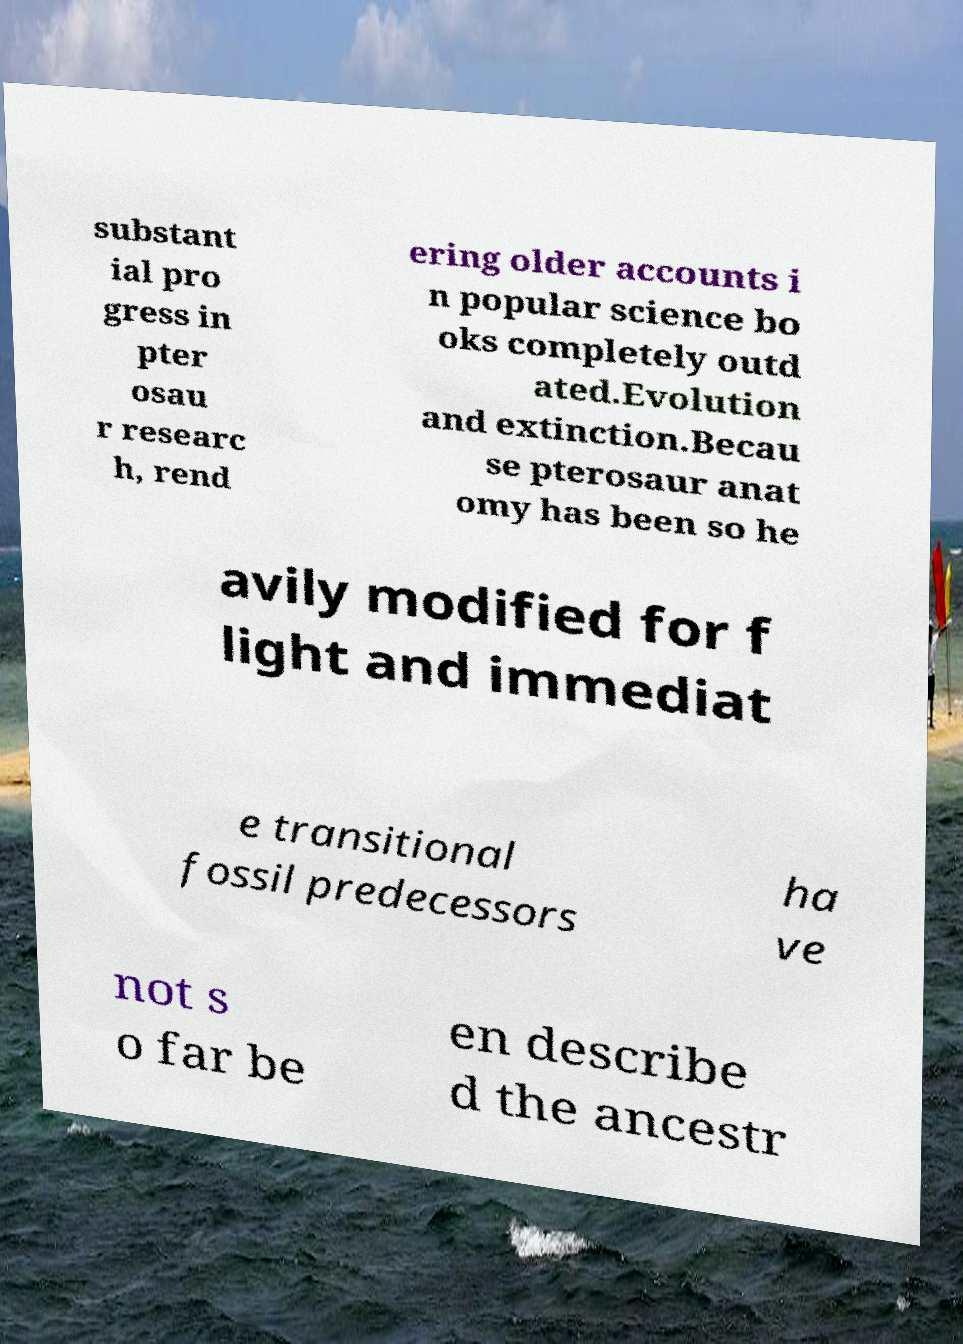There's text embedded in this image that I need extracted. Can you transcribe it verbatim? substant ial pro gress in pter osau r researc h, rend ering older accounts i n popular science bo oks completely outd ated.Evolution and extinction.Becau se pterosaur anat omy has been so he avily modified for f light and immediat e transitional fossil predecessors ha ve not s o far be en describe d the ancestr 